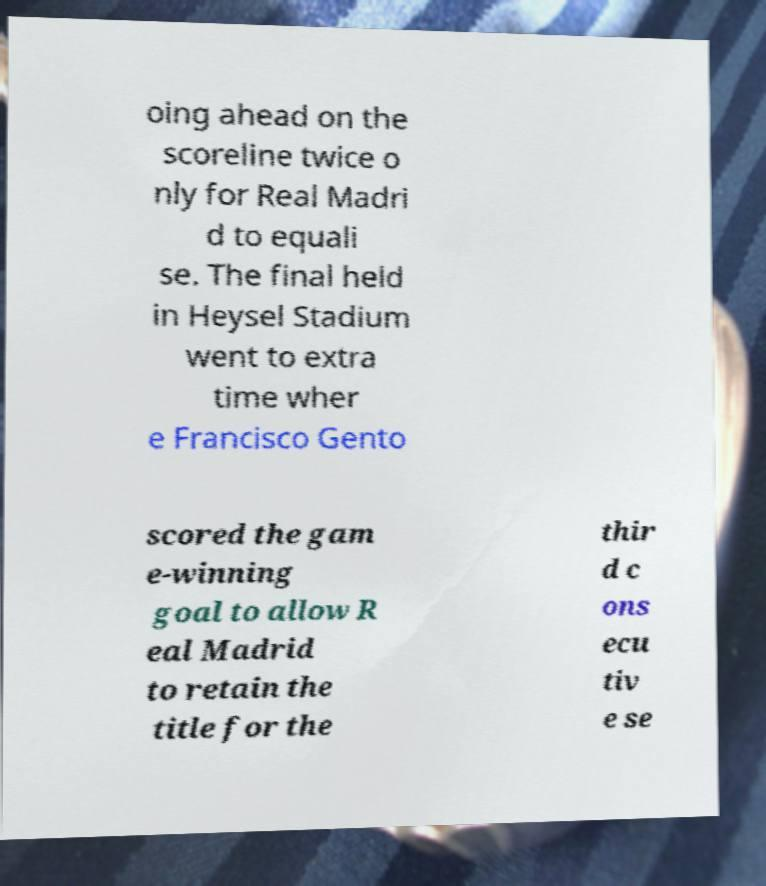I need the written content from this picture converted into text. Can you do that? oing ahead on the scoreline twice o nly for Real Madri d to equali se. The final held in Heysel Stadium went to extra time wher e Francisco Gento scored the gam e-winning goal to allow R eal Madrid to retain the title for the thir d c ons ecu tiv e se 